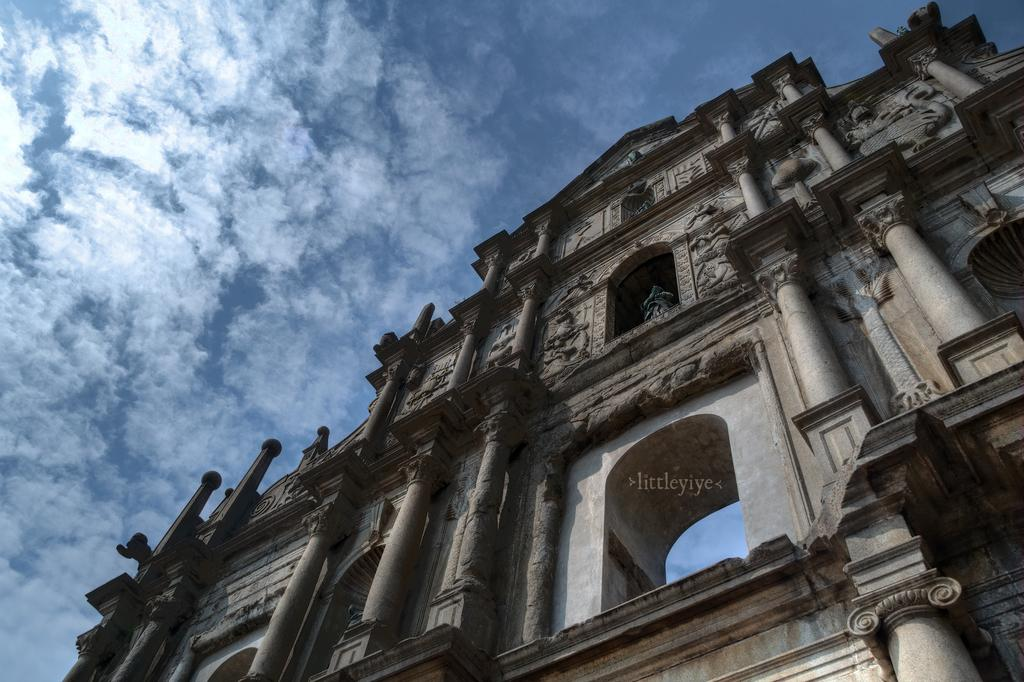What type of structure is present in the image? There is a building in the image. What artistic elements can be seen in the image? There are sculptures in the image. What is visible at the top of the image? The sky is visible at the top of the image. What type of machine is being used by the snake in the image? There is no snake or machine present in the image. How does the mother interact with the sculptures in the image? There is no mother present in the image, and therefore no interaction with the sculptures can be observed. 